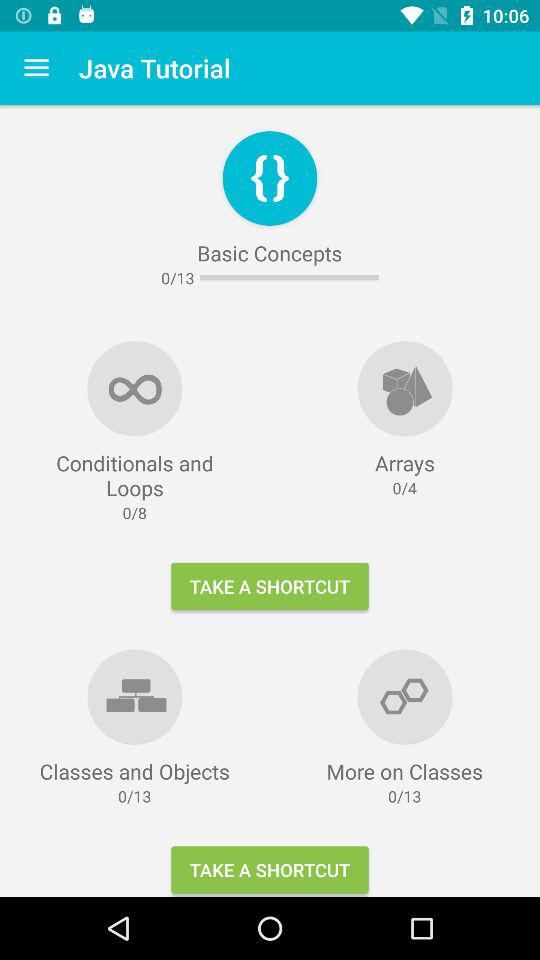How many modules in total are there in "Classes and Objects" in "Java Tutorial"? There are 13 modules in total in "Classes and Objects" in "Java Tutorial". 